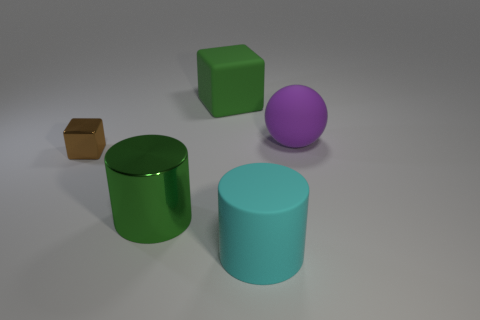Add 4 tiny gray metallic cubes. How many objects exist? 9 Subtract all cyan cylinders. How many cylinders are left? 1 Subtract 1 cylinders. How many cylinders are left? 1 Subtract 0 blue cylinders. How many objects are left? 5 Subtract all balls. How many objects are left? 4 Subtract all red cubes. Subtract all brown cylinders. How many cubes are left? 2 Subtract all big metallic cylinders. Subtract all tiny brown cubes. How many objects are left? 3 Add 1 cyan matte cylinders. How many cyan matte cylinders are left? 2 Add 5 blue metallic cylinders. How many blue metallic cylinders exist? 5 